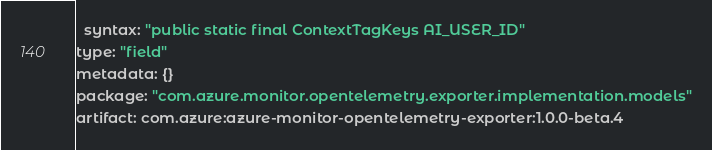Convert code to text. <code><loc_0><loc_0><loc_500><loc_500><_YAML_>  syntax: "public static final ContextTagKeys AI_USER_ID"
type: "field"
metadata: {}
package: "com.azure.monitor.opentelemetry.exporter.implementation.models"
artifact: com.azure:azure-monitor-opentelemetry-exporter:1.0.0-beta.4
</code> 